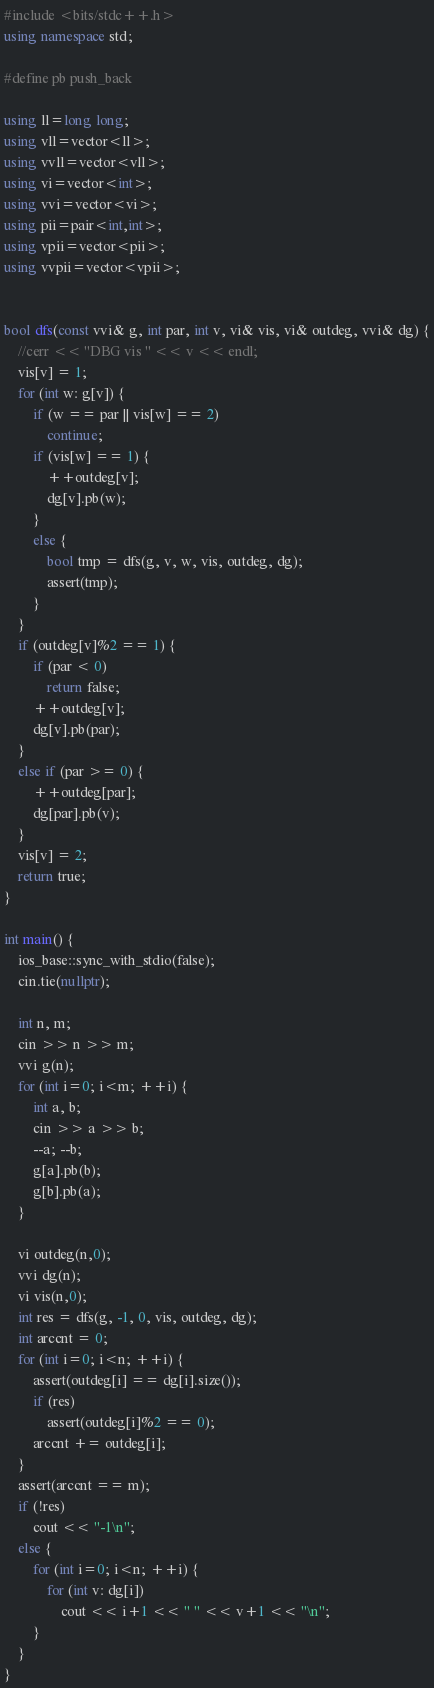<code> <loc_0><loc_0><loc_500><loc_500><_C++_>#include <bits/stdc++.h>
using namespace std;

#define pb push_back

using ll=long long;
using vll=vector<ll>;
using vvll=vector<vll>;
using vi=vector<int>;
using vvi=vector<vi>;
using pii=pair<int,int>;
using vpii=vector<pii>;
using vvpii=vector<vpii>;


bool dfs(const vvi& g, int par, int v, vi& vis, vi& outdeg, vvi& dg) {
    //cerr << "DBG vis " << v << endl;
    vis[v] = 1;
    for (int w: g[v]) {
        if (w == par || vis[w] == 2)
            continue;
        if (vis[w] == 1) {
            ++outdeg[v];
            dg[v].pb(w);
        }
        else {
            bool tmp = dfs(g, v, w, vis, outdeg, dg);
            assert(tmp);
        }
    }
    if (outdeg[v]%2 == 1) {
        if (par < 0)
            return false;
        ++outdeg[v];
        dg[v].pb(par);
    }
    else if (par >= 0) {
        ++outdeg[par];
        dg[par].pb(v);
    }
    vis[v] = 2;
    return true;
}

int main() {
    ios_base::sync_with_stdio(false);
    cin.tie(nullptr);

    int n, m;
    cin >> n >> m;
    vvi g(n);
    for (int i=0; i<m; ++i) {
        int a, b;
        cin >> a >> b;
        --a; --b;
        g[a].pb(b);
        g[b].pb(a);
    }

    vi outdeg(n,0);
    vvi dg(n);
    vi vis(n,0);
    int res = dfs(g, -1, 0, vis, outdeg, dg);
    int arccnt = 0;
    for (int i=0; i<n; ++i) {
        assert(outdeg[i] == dg[i].size());
        if (res)
            assert(outdeg[i]%2 == 0);
        arccnt += outdeg[i];
    }
    assert(arccnt == m);
    if (!res)
        cout << "-1\n";
    else {
        for (int i=0; i<n; ++i) {
            for (int v: dg[i])
                cout << i+1 << " " << v+1 << "\n";
        }
    }
}
</code> 